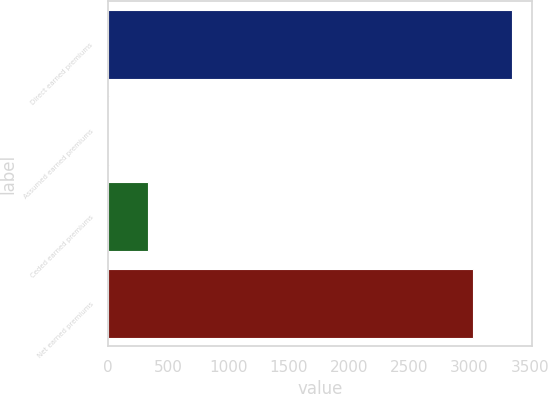Convert chart. <chart><loc_0><loc_0><loc_500><loc_500><bar_chart><fcel>Direct earned premiums<fcel>Assumed earned premiums<fcel>Ceded earned premiums<fcel>Net earned premiums<nl><fcel>3351.4<fcel>12<fcel>334.4<fcel>3029<nl></chart> 